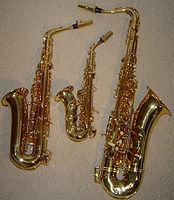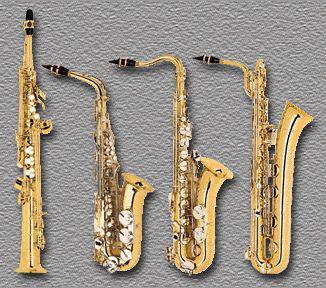The first image is the image on the left, the second image is the image on the right. Analyze the images presented: Is the assertion "Four instruments are lined up together in the image on the left." valid? Answer yes or no. No. The first image is the image on the left, the second image is the image on the right. Evaluate the accuracy of this statement regarding the images: "Right and left images each show four instruments, including one that is straight and three with curved mouthpieces and bell ends.". Is it true? Answer yes or no. No. 